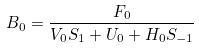Convert formula to latex. <formula><loc_0><loc_0><loc_500><loc_500>B _ { 0 } = \frac { F _ { 0 } } { V _ { 0 } S _ { 1 } + U _ { 0 } + H _ { 0 } S _ { - 1 } }</formula> 